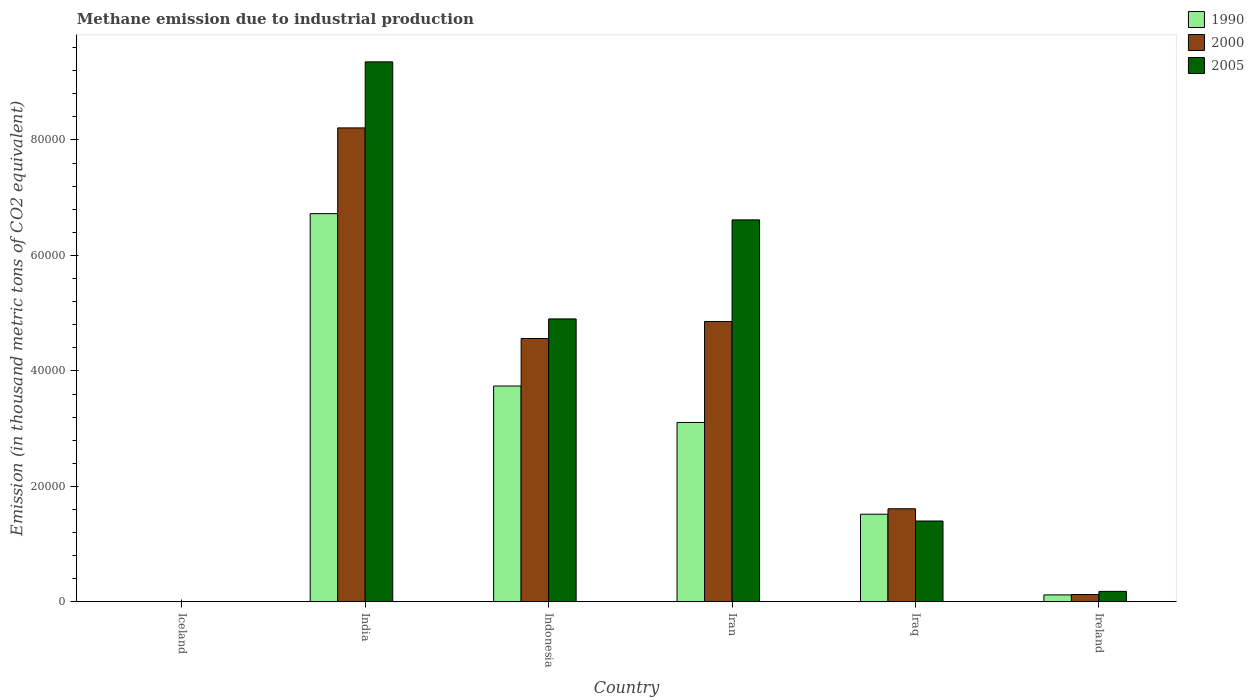How many groups of bars are there?
Offer a very short reply. 6. Are the number of bars on each tick of the X-axis equal?
Your response must be concise. Yes. How many bars are there on the 1st tick from the right?
Your response must be concise. 3. Across all countries, what is the maximum amount of methane emitted in 2000?
Provide a succinct answer. 8.21e+04. In which country was the amount of methane emitted in 2005 maximum?
Ensure brevity in your answer.  India. What is the total amount of methane emitted in 2000 in the graph?
Make the answer very short. 1.94e+05. What is the difference between the amount of methane emitted in 2000 in Indonesia and that in Iran?
Provide a succinct answer. -2945.6. What is the difference between the amount of methane emitted in 1990 in Ireland and the amount of methane emitted in 2000 in Iran?
Your answer should be very brief. -4.74e+04. What is the average amount of methane emitted in 2005 per country?
Your answer should be compact. 3.74e+04. What is the difference between the amount of methane emitted of/in 2000 and amount of methane emitted of/in 1990 in Ireland?
Your response must be concise. 68.5. What is the ratio of the amount of methane emitted in 2005 in Indonesia to that in Iran?
Your response must be concise. 0.74. Is the difference between the amount of methane emitted in 2000 in India and Ireland greater than the difference between the amount of methane emitted in 1990 in India and Ireland?
Keep it short and to the point. Yes. What is the difference between the highest and the second highest amount of methane emitted in 2005?
Provide a short and direct response. -4.45e+04. What is the difference between the highest and the lowest amount of methane emitted in 2000?
Your response must be concise. 8.21e+04. What does the 3rd bar from the left in India represents?
Provide a short and direct response. 2005. What is the difference between two consecutive major ticks on the Y-axis?
Ensure brevity in your answer.  2.00e+04. Does the graph contain any zero values?
Your response must be concise. No. Does the graph contain grids?
Ensure brevity in your answer.  No. How many legend labels are there?
Offer a very short reply. 3. What is the title of the graph?
Ensure brevity in your answer.  Methane emission due to industrial production. Does "1966" appear as one of the legend labels in the graph?
Your answer should be very brief. No. What is the label or title of the X-axis?
Make the answer very short. Country. What is the label or title of the Y-axis?
Offer a very short reply. Emission (in thousand metric tons of CO2 equivalent). What is the Emission (in thousand metric tons of CO2 equivalent) of 2000 in Iceland?
Provide a succinct answer. 5.6. What is the Emission (in thousand metric tons of CO2 equivalent) in 1990 in India?
Offer a terse response. 6.72e+04. What is the Emission (in thousand metric tons of CO2 equivalent) in 2000 in India?
Offer a terse response. 8.21e+04. What is the Emission (in thousand metric tons of CO2 equivalent) of 2005 in India?
Make the answer very short. 9.35e+04. What is the Emission (in thousand metric tons of CO2 equivalent) of 1990 in Indonesia?
Your answer should be compact. 3.74e+04. What is the Emission (in thousand metric tons of CO2 equivalent) in 2000 in Indonesia?
Provide a succinct answer. 4.56e+04. What is the Emission (in thousand metric tons of CO2 equivalent) of 2005 in Indonesia?
Give a very brief answer. 4.90e+04. What is the Emission (in thousand metric tons of CO2 equivalent) in 1990 in Iran?
Your answer should be compact. 3.11e+04. What is the Emission (in thousand metric tons of CO2 equivalent) of 2000 in Iran?
Make the answer very short. 4.86e+04. What is the Emission (in thousand metric tons of CO2 equivalent) in 2005 in Iran?
Offer a very short reply. 6.62e+04. What is the Emission (in thousand metric tons of CO2 equivalent) in 1990 in Iraq?
Give a very brief answer. 1.52e+04. What is the Emission (in thousand metric tons of CO2 equivalent) of 2000 in Iraq?
Give a very brief answer. 1.61e+04. What is the Emission (in thousand metric tons of CO2 equivalent) of 2005 in Iraq?
Keep it short and to the point. 1.40e+04. What is the Emission (in thousand metric tons of CO2 equivalent) of 1990 in Ireland?
Your response must be concise. 1208.4. What is the Emission (in thousand metric tons of CO2 equivalent) of 2000 in Ireland?
Make the answer very short. 1276.9. What is the Emission (in thousand metric tons of CO2 equivalent) of 2005 in Ireland?
Keep it short and to the point. 1817.5. Across all countries, what is the maximum Emission (in thousand metric tons of CO2 equivalent) in 1990?
Your answer should be compact. 6.72e+04. Across all countries, what is the maximum Emission (in thousand metric tons of CO2 equivalent) in 2000?
Provide a succinct answer. 8.21e+04. Across all countries, what is the maximum Emission (in thousand metric tons of CO2 equivalent) in 2005?
Provide a succinct answer. 9.35e+04. Across all countries, what is the minimum Emission (in thousand metric tons of CO2 equivalent) of 2005?
Keep it short and to the point. 4. What is the total Emission (in thousand metric tons of CO2 equivalent) in 1990 in the graph?
Your answer should be very brief. 1.52e+05. What is the total Emission (in thousand metric tons of CO2 equivalent) of 2000 in the graph?
Make the answer very short. 1.94e+05. What is the total Emission (in thousand metric tons of CO2 equivalent) of 2005 in the graph?
Make the answer very short. 2.25e+05. What is the difference between the Emission (in thousand metric tons of CO2 equivalent) in 1990 in Iceland and that in India?
Give a very brief answer. -6.72e+04. What is the difference between the Emission (in thousand metric tons of CO2 equivalent) in 2000 in Iceland and that in India?
Give a very brief answer. -8.21e+04. What is the difference between the Emission (in thousand metric tons of CO2 equivalent) of 2005 in Iceland and that in India?
Offer a terse response. -9.35e+04. What is the difference between the Emission (in thousand metric tons of CO2 equivalent) in 1990 in Iceland and that in Indonesia?
Provide a succinct answer. -3.74e+04. What is the difference between the Emission (in thousand metric tons of CO2 equivalent) of 2000 in Iceland and that in Indonesia?
Ensure brevity in your answer.  -4.56e+04. What is the difference between the Emission (in thousand metric tons of CO2 equivalent) in 2005 in Iceland and that in Indonesia?
Provide a short and direct response. -4.90e+04. What is the difference between the Emission (in thousand metric tons of CO2 equivalent) of 1990 in Iceland and that in Iran?
Make the answer very short. -3.11e+04. What is the difference between the Emission (in thousand metric tons of CO2 equivalent) in 2000 in Iceland and that in Iran?
Provide a short and direct response. -4.86e+04. What is the difference between the Emission (in thousand metric tons of CO2 equivalent) of 2005 in Iceland and that in Iran?
Offer a very short reply. -6.62e+04. What is the difference between the Emission (in thousand metric tons of CO2 equivalent) of 1990 in Iceland and that in Iraq?
Provide a succinct answer. -1.52e+04. What is the difference between the Emission (in thousand metric tons of CO2 equivalent) of 2000 in Iceland and that in Iraq?
Provide a short and direct response. -1.61e+04. What is the difference between the Emission (in thousand metric tons of CO2 equivalent) of 2005 in Iceland and that in Iraq?
Provide a succinct answer. -1.40e+04. What is the difference between the Emission (in thousand metric tons of CO2 equivalent) of 1990 in Iceland and that in Ireland?
Your answer should be very brief. -1201.4. What is the difference between the Emission (in thousand metric tons of CO2 equivalent) in 2000 in Iceland and that in Ireland?
Offer a terse response. -1271.3. What is the difference between the Emission (in thousand metric tons of CO2 equivalent) in 2005 in Iceland and that in Ireland?
Make the answer very short. -1813.5. What is the difference between the Emission (in thousand metric tons of CO2 equivalent) of 1990 in India and that in Indonesia?
Offer a terse response. 2.99e+04. What is the difference between the Emission (in thousand metric tons of CO2 equivalent) in 2000 in India and that in Indonesia?
Give a very brief answer. 3.65e+04. What is the difference between the Emission (in thousand metric tons of CO2 equivalent) in 2005 in India and that in Indonesia?
Provide a short and direct response. 4.45e+04. What is the difference between the Emission (in thousand metric tons of CO2 equivalent) of 1990 in India and that in Iran?
Ensure brevity in your answer.  3.62e+04. What is the difference between the Emission (in thousand metric tons of CO2 equivalent) of 2000 in India and that in Iran?
Ensure brevity in your answer.  3.35e+04. What is the difference between the Emission (in thousand metric tons of CO2 equivalent) in 2005 in India and that in Iran?
Offer a very short reply. 2.74e+04. What is the difference between the Emission (in thousand metric tons of CO2 equivalent) in 1990 in India and that in Iraq?
Provide a succinct answer. 5.21e+04. What is the difference between the Emission (in thousand metric tons of CO2 equivalent) of 2000 in India and that in Iraq?
Offer a terse response. 6.60e+04. What is the difference between the Emission (in thousand metric tons of CO2 equivalent) of 2005 in India and that in Iraq?
Give a very brief answer. 7.95e+04. What is the difference between the Emission (in thousand metric tons of CO2 equivalent) of 1990 in India and that in Ireland?
Your answer should be compact. 6.60e+04. What is the difference between the Emission (in thousand metric tons of CO2 equivalent) of 2000 in India and that in Ireland?
Provide a succinct answer. 8.08e+04. What is the difference between the Emission (in thousand metric tons of CO2 equivalent) of 2005 in India and that in Ireland?
Give a very brief answer. 9.17e+04. What is the difference between the Emission (in thousand metric tons of CO2 equivalent) in 1990 in Indonesia and that in Iran?
Provide a short and direct response. 6313.9. What is the difference between the Emission (in thousand metric tons of CO2 equivalent) of 2000 in Indonesia and that in Iran?
Make the answer very short. -2945.6. What is the difference between the Emission (in thousand metric tons of CO2 equivalent) of 2005 in Indonesia and that in Iran?
Your answer should be compact. -1.72e+04. What is the difference between the Emission (in thousand metric tons of CO2 equivalent) of 1990 in Indonesia and that in Iraq?
Make the answer very short. 2.22e+04. What is the difference between the Emission (in thousand metric tons of CO2 equivalent) in 2000 in Indonesia and that in Iraq?
Your answer should be very brief. 2.95e+04. What is the difference between the Emission (in thousand metric tons of CO2 equivalent) of 2005 in Indonesia and that in Iraq?
Offer a very short reply. 3.50e+04. What is the difference between the Emission (in thousand metric tons of CO2 equivalent) of 1990 in Indonesia and that in Ireland?
Offer a very short reply. 3.62e+04. What is the difference between the Emission (in thousand metric tons of CO2 equivalent) of 2000 in Indonesia and that in Ireland?
Your response must be concise. 4.43e+04. What is the difference between the Emission (in thousand metric tons of CO2 equivalent) of 2005 in Indonesia and that in Ireland?
Make the answer very short. 4.72e+04. What is the difference between the Emission (in thousand metric tons of CO2 equivalent) in 1990 in Iran and that in Iraq?
Make the answer very short. 1.59e+04. What is the difference between the Emission (in thousand metric tons of CO2 equivalent) in 2000 in Iran and that in Iraq?
Give a very brief answer. 3.24e+04. What is the difference between the Emission (in thousand metric tons of CO2 equivalent) of 2005 in Iran and that in Iraq?
Keep it short and to the point. 5.22e+04. What is the difference between the Emission (in thousand metric tons of CO2 equivalent) in 1990 in Iran and that in Ireland?
Make the answer very short. 2.99e+04. What is the difference between the Emission (in thousand metric tons of CO2 equivalent) of 2000 in Iran and that in Ireland?
Give a very brief answer. 4.73e+04. What is the difference between the Emission (in thousand metric tons of CO2 equivalent) of 2005 in Iran and that in Ireland?
Your answer should be compact. 6.43e+04. What is the difference between the Emission (in thousand metric tons of CO2 equivalent) in 1990 in Iraq and that in Ireland?
Give a very brief answer. 1.40e+04. What is the difference between the Emission (in thousand metric tons of CO2 equivalent) of 2000 in Iraq and that in Ireland?
Your response must be concise. 1.48e+04. What is the difference between the Emission (in thousand metric tons of CO2 equivalent) in 2005 in Iraq and that in Ireland?
Your answer should be very brief. 1.22e+04. What is the difference between the Emission (in thousand metric tons of CO2 equivalent) in 1990 in Iceland and the Emission (in thousand metric tons of CO2 equivalent) in 2000 in India?
Your answer should be very brief. -8.21e+04. What is the difference between the Emission (in thousand metric tons of CO2 equivalent) in 1990 in Iceland and the Emission (in thousand metric tons of CO2 equivalent) in 2005 in India?
Keep it short and to the point. -9.35e+04. What is the difference between the Emission (in thousand metric tons of CO2 equivalent) in 2000 in Iceland and the Emission (in thousand metric tons of CO2 equivalent) in 2005 in India?
Give a very brief answer. -9.35e+04. What is the difference between the Emission (in thousand metric tons of CO2 equivalent) of 1990 in Iceland and the Emission (in thousand metric tons of CO2 equivalent) of 2000 in Indonesia?
Give a very brief answer. -4.56e+04. What is the difference between the Emission (in thousand metric tons of CO2 equivalent) in 1990 in Iceland and the Emission (in thousand metric tons of CO2 equivalent) in 2005 in Indonesia?
Offer a very short reply. -4.90e+04. What is the difference between the Emission (in thousand metric tons of CO2 equivalent) in 2000 in Iceland and the Emission (in thousand metric tons of CO2 equivalent) in 2005 in Indonesia?
Provide a short and direct response. -4.90e+04. What is the difference between the Emission (in thousand metric tons of CO2 equivalent) in 1990 in Iceland and the Emission (in thousand metric tons of CO2 equivalent) in 2000 in Iran?
Ensure brevity in your answer.  -4.86e+04. What is the difference between the Emission (in thousand metric tons of CO2 equivalent) in 1990 in Iceland and the Emission (in thousand metric tons of CO2 equivalent) in 2005 in Iran?
Offer a very short reply. -6.62e+04. What is the difference between the Emission (in thousand metric tons of CO2 equivalent) in 2000 in Iceland and the Emission (in thousand metric tons of CO2 equivalent) in 2005 in Iran?
Offer a very short reply. -6.62e+04. What is the difference between the Emission (in thousand metric tons of CO2 equivalent) in 1990 in Iceland and the Emission (in thousand metric tons of CO2 equivalent) in 2000 in Iraq?
Your answer should be very brief. -1.61e+04. What is the difference between the Emission (in thousand metric tons of CO2 equivalent) of 1990 in Iceland and the Emission (in thousand metric tons of CO2 equivalent) of 2005 in Iraq?
Provide a succinct answer. -1.40e+04. What is the difference between the Emission (in thousand metric tons of CO2 equivalent) in 2000 in Iceland and the Emission (in thousand metric tons of CO2 equivalent) in 2005 in Iraq?
Give a very brief answer. -1.40e+04. What is the difference between the Emission (in thousand metric tons of CO2 equivalent) of 1990 in Iceland and the Emission (in thousand metric tons of CO2 equivalent) of 2000 in Ireland?
Your answer should be very brief. -1269.9. What is the difference between the Emission (in thousand metric tons of CO2 equivalent) of 1990 in Iceland and the Emission (in thousand metric tons of CO2 equivalent) of 2005 in Ireland?
Make the answer very short. -1810.5. What is the difference between the Emission (in thousand metric tons of CO2 equivalent) of 2000 in Iceland and the Emission (in thousand metric tons of CO2 equivalent) of 2005 in Ireland?
Give a very brief answer. -1811.9. What is the difference between the Emission (in thousand metric tons of CO2 equivalent) of 1990 in India and the Emission (in thousand metric tons of CO2 equivalent) of 2000 in Indonesia?
Your response must be concise. 2.16e+04. What is the difference between the Emission (in thousand metric tons of CO2 equivalent) of 1990 in India and the Emission (in thousand metric tons of CO2 equivalent) of 2005 in Indonesia?
Your response must be concise. 1.82e+04. What is the difference between the Emission (in thousand metric tons of CO2 equivalent) in 2000 in India and the Emission (in thousand metric tons of CO2 equivalent) in 2005 in Indonesia?
Make the answer very short. 3.31e+04. What is the difference between the Emission (in thousand metric tons of CO2 equivalent) in 1990 in India and the Emission (in thousand metric tons of CO2 equivalent) in 2000 in Iran?
Make the answer very short. 1.87e+04. What is the difference between the Emission (in thousand metric tons of CO2 equivalent) of 1990 in India and the Emission (in thousand metric tons of CO2 equivalent) of 2005 in Iran?
Your response must be concise. 1080. What is the difference between the Emission (in thousand metric tons of CO2 equivalent) of 2000 in India and the Emission (in thousand metric tons of CO2 equivalent) of 2005 in Iran?
Offer a very short reply. 1.59e+04. What is the difference between the Emission (in thousand metric tons of CO2 equivalent) in 1990 in India and the Emission (in thousand metric tons of CO2 equivalent) in 2000 in Iraq?
Provide a succinct answer. 5.11e+04. What is the difference between the Emission (in thousand metric tons of CO2 equivalent) of 1990 in India and the Emission (in thousand metric tons of CO2 equivalent) of 2005 in Iraq?
Provide a succinct answer. 5.32e+04. What is the difference between the Emission (in thousand metric tons of CO2 equivalent) of 2000 in India and the Emission (in thousand metric tons of CO2 equivalent) of 2005 in Iraq?
Your response must be concise. 6.81e+04. What is the difference between the Emission (in thousand metric tons of CO2 equivalent) of 1990 in India and the Emission (in thousand metric tons of CO2 equivalent) of 2000 in Ireland?
Your response must be concise. 6.60e+04. What is the difference between the Emission (in thousand metric tons of CO2 equivalent) in 1990 in India and the Emission (in thousand metric tons of CO2 equivalent) in 2005 in Ireland?
Offer a terse response. 6.54e+04. What is the difference between the Emission (in thousand metric tons of CO2 equivalent) of 2000 in India and the Emission (in thousand metric tons of CO2 equivalent) of 2005 in Ireland?
Your answer should be compact. 8.03e+04. What is the difference between the Emission (in thousand metric tons of CO2 equivalent) of 1990 in Indonesia and the Emission (in thousand metric tons of CO2 equivalent) of 2000 in Iran?
Make the answer very short. -1.12e+04. What is the difference between the Emission (in thousand metric tons of CO2 equivalent) in 1990 in Indonesia and the Emission (in thousand metric tons of CO2 equivalent) in 2005 in Iran?
Give a very brief answer. -2.88e+04. What is the difference between the Emission (in thousand metric tons of CO2 equivalent) of 2000 in Indonesia and the Emission (in thousand metric tons of CO2 equivalent) of 2005 in Iran?
Provide a succinct answer. -2.05e+04. What is the difference between the Emission (in thousand metric tons of CO2 equivalent) in 1990 in Indonesia and the Emission (in thousand metric tons of CO2 equivalent) in 2000 in Iraq?
Offer a terse response. 2.13e+04. What is the difference between the Emission (in thousand metric tons of CO2 equivalent) in 1990 in Indonesia and the Emission (in thousand metric tons of CO2 equivalent) in 2005 in Iraq?
Provide a short and direct response. 2.34e+04. What is the difference between the Emission (in thousand metric tons of CO2 equivalent) in 2000 in Indonesia and the Emission (in thousand metric tons of CO2 equivalent) in 2005 in Iraq?
Provide a short and direct response. 3.16e+04. What is the difference between the Emission (in thousand metric tons of CO2 equivalent) of 1990 in Indonesia and the Emission (in thousand metric tons of CO2 equivalent) of 2000 in Ireland?
Give a very brief answer. 3.61e+04. What is the difference between the Emission (in thousand metric tons of CO2 equivalent) of 1990 in Indonesia and the Emission (in thousand metric tons of CO2 equivalent) of 2005 in Ireland?
Keep it short and to the point. 3.56e+04. What is the difference between the Emission (in thousand metric tons of CO2 equivalent) in 2000 in Indonesia and the Emission (in thousand metric tons of CO2 equivalent) in 2005 in Ireland?
Ensure brevity in your answer.  4.38e+04. What is the difference between the Emission (in thousand metric tons of CO2 equivalent) of 1990 in Iran and the Emission (in thousand metric tons of CO2 equivalent) of 2000 in Iraq?
Give a very brief answer. 1.49e+04. What is the difference between the Emission (in thousand metric tons of CO2 equivalent) of 1990 in Iran and the Emission (in thousand metric tons of CO2 equivalent) of 2005 in Iraq?
Your answer should be very brief. 1.71e+04. What is the difference between the Emission (in thousand metric tons of CO2 equivalent) of 2000 in Iran and the Emission (in thousand metric tons of CO2 equivalent) of 2005 in Iraq?
Your answer should be compact. 3.46e+04. What is the difference between the Emission (in thousand metric tons of CO2 equivalent) in 1990 in Iran and the Emission (in thousand metric tons of CO2 equivalent) in 2000 in Ireland?
Your response must be concise. 2.98e+04. What is the difference between the Emission (in thousand metric tons of CO2 equivalent) in 1990 in Iran and the Emission (in thousand metric tons of CO2 equivalent) in 2005 in Ireland?
Provide a short and direct response. 2.93e+04. What is the difference between the Emission (in thousand metric tons of CO2 equivalent) of 2000 in Iran and the Emission (in thousand metric tons of CO2 equivalent) of 2005 in Ireland?
Ensure brevity in your answer.  4.67e+04. What is the difference between the Emission (in thousand metric tons of CO2 equivalent) of 1990 in Iraq and the Emission (in thousand metric tons of CO2 equivalent) of 2000 in Ireland?
Make the answer very short. 1.39e+04. What is the difference between the Emission (in thousand metric tons of CO2 equivalent) in 1990 in Iraq and the Emission (in thousand metric tons of CO2 equivalent) in 2005 in Ireland?
Give a very brief answer. 1.34e+04. What is the difference between the Emission (in thousand metric tons of CO2 equivalent) in 2000 in Iraq and the Emission (in thousand metric tons of CO2 equivalent) in 2005 in Ireland?
Provide a short and direct response. 1.43e+04. What is the average Emission (in thousand metric tons of CO2 equivalent) of 1990 per country?
Make the answer very short. 2.53e+04. What is the average Emission (in thousand metric tons of CO2 equivalent) in 2000 per country?
Provide a short and direct response. 3.23e+04. What is the average Emission (in thousand metric tons of CO2 equivalent) of 2005 per country?
Ensure brevity in your answer.  3.74e+04. What is the difference between the Emission (in thousand metric tons of CO2 equivalent) in 1990 and Emission (in thousand metric tons of CO2 equivalent) in 2000 in Iceland?
Ensure brevity in your answer.  1.4. What is the difference between the Emission (in thousand metric tons of CO2 equivalent) in 1990 and Emission (in thousand metric tons of CO2 equivalent) in 2005 in Iceland?
Ensure brevity in your answer.  3. What is the difference between the Emission (in thousand metric tons of CO2 equivalent) of 1990 and Emission (in thousand metric tons of CO2 equivalent) of 2000 in India?
Keep it short and to the point. -1.49e+04. What is the difference between the Emission (in thousand metric tons of CO2 equivalent) in 1990 and Emission (in thousand metric tons of CO2 equivalent) in 2005 in India?
Your answer should be very brief. -2.63e+04. What is the difference between the Emission (in thousand metric tons of CO2 equivalent) in 2000 and Emission (in thousand metric tons of CO2 equivalent) in 2005 in India?
Provide a short and direct response. -1.14e+04. What is the difference between the Emission (in thousand metric tons of CO2 equivalent) of 1990 and Emission (in thousand metric tons of CO2 equivalent) of 2000 in Indonesia?
Give a very brief answer. -8228.1. What is the difference between the Emission (in thousand metric tons of CO2 equivalent) in 1990 and Emission (in thousand metric tons of CO2 equivalent) in 2005 in Indonesia?
Offer a terse response. -1.16e+04. What is the difference between the Emission (in thousand metric tons of CO2 equivalent) of 2000 and Emission (in thousand metric tons of CO2 equivalent) of 2005 in Indonesia?
Keep it short and to the point. -3391.6. What is the difference between the Emission (in thousand metric tons of CO2 equivalent) of 1990 and Emission (in thousand metric tons of CO2 equivalent) of 2000 in Iran?
Give a very brief answer. -1.75e+04. What is the difference between the Emission (in thousand metric tons of CO2 equivalent) of 1990 and Emission (in thousand metric tons of CO2 equivalent) of 2005 in Iran?
Provide a succinct answer. -3.51e+04. What is the difference between the Emission (in thousand metric tons of CO2 equivalent) in 2000 and Emission (in thousand metric tons of CO2 equivalent) in 2005 in Iran?
Provide a succinct answer. -1.76e+04. What is the difference between the Emission (in thousand metric tons of CO2 equivalent) of 1990 and Emission (in thousand metric tons of CO2 equivalent) of 2000 in Iraq?
Keep it short and to the point. -942.5. What is the difference between the Emission (in thousand metric tons of CO2 equivalent) in 1990 and Emission (in thousand metric tons of CO2 equivalent) in 2005 in Iraq?
Offer a very short reply. 1177.5. What is the difference between the Emission (in thousand metric tons of CO2 equivalent) of 2000 and Emission (in thousand metric tons of CO2 equivalent) of 2005 in Iraq?
Your answer should be very brief. 2120. What is the difference between the Emission (in thousand metric tons of CO2 equivalent) in 1990 and Emission (in thousand metric tons of CO2 equivalent) in 2000 in Ireland?
Keep it short and to the point. -68.5. What is the difference between the Emission (in thousand metric tons of CO2 equivalent) of 1990 and Emission (in thousand metric tons of CO2 equivalent) of 2005 in Ireland?
Give a very brief answer. -609.1. What is the difference between the Emission (in thousand metric tons of CO2 equivalent) in 2000 and Emission (in thousand metric tons of CO2 equivalent) in 2005 in Ireland?
Provide a succinct answer. -540.6. What is the ratio of the Emission (in thousand metric tons of CO2 equivalent) of 2005 in Iceland to that in India?
Your answer should be very brief. 0. What is the ratio of the Emission (in thousand metric tons of CO2 equivalent) in 1990 in Iceland to that in Indonesia?
Provide a short and direct response. 0. What is the ratio of the Emission (in thousand metric tons of CO2 equivalent) of 2005 in Iceland to that in Indonesia?
Keep it short and to the point. 0. What is the ratio of the Emission (in thousand metric tons of CO2 equivalent) of 1990 in Iceland to that in Iran?
Offer a terse response. 0. What is the ratio of the Emission (in thousand metric tons of CO2 equivalent) in 2000 in Iceland to that in Iran?
Offer a very short reply. 0. What is the ratio of the Emission (in thousand metric tons of CO2 equivalent) in 2005 in Iceland to that in Iran?
Provide a short and direct response. 0. What is the ratio of the Emission (in thousand metric tons of CO2 equivalent) in 1990 in Iceland to that in Ireland?
Provide a short and direct response. 0.01. What is the ratio of the Emission (in thousand metric tons of CO2 equivalent) in 2000 in Iceland to that in Ireland?
Keep it short and to the point. 0. What is the ratio of the Emission (in thousand metric tons of CO2 equivalent) in 2005 in Iceland to that in Ireland?
Offer a very short reply. 0. What is the ratio of the Emission (in thousand metric tons of CO2 equivalent) of 1990 in India to that in Indonesia?
Make the answer very short. 1.8. What is the ratio of the Emission (in thousand metric tons of CO2 equivalent) in 2000 in India to that in Indonesia?
Provide a short and direct response. 1.8. What is the ratio of the Emission (in thousand metric tons of CO2 equivalent) in 2005 in India to that in Indonesia?
Ensure brevity in your answer.  1.91. What is the ratio of the Emission (in thousand metric tons of CO2 equivalent) of 1990 in India to that in Iran?
Your answer should be compact. 2.16. What is the ratio of the Emission (in thousand metric tons of CO2 equivalent) in 2000 in India to that in Iran?
Ensure brevity in your answer.  1.69. What is the ratio of the Emission (in thousand metric tons of CO2 equivalent) in 2005 in India to that in Iran?
Your answer should be very brief. 1.41. What is the ratio of the Emission (in thousand metric tons of CO2 equivalent) of 1990 in India to that in Iraq?
Give a very brief answer. 4.43. What is the ratio of the Emission (in thousand metric tons of CO2 equivalent) of 2000 in India to that in Iraq?
Offer a terse response. 5.09. What is the ratio of the Emission (in thousand metric tons of CO2 equivalent) of 2005 in India to that in Iraq?
Offer a terse response. 6.68. What is the ratio of the Emission (in thousand metric tons of CO2 equivalent) of 1990 in India to that in Ireland?
Ensure brevity in your answer.  55.64. What is the ratio of the Emission (in thousand metric tons of CO2 equivalent) in 2000 in India to that in Ireland?
Your answer should be very brief. 64.29. What is the ratio of the Emission (in thousand metric tons of CO2 equivalent) in 2005 in India to that in Ireland?
Your answer should be compact. 51.46. What is the ratio of the Emission (in thousand metric tons of CO2 equivalent) of 1990 in Indonesia to that in Iran?
Give a very brief answer. 1.2. What is the ratio of the Emission (in thousand metric tons of CO2 equivalent) of 2000 in Indonesia to that in Iran?
Provide a succinct answer. 0.94. What is the ratio of the Emission (in thousand metric tons of CO2 equivalent) of 2005 in Indonesia to that in Iran?
Ensure brevity in your answer.  0.74. What is the ratio of the Emission (in thousand metric tons of CO2 equivalent) in 1990 in Indonesia to that in Iraq?
Ensure brevity in your answer.  2.46. What is the ratio of the Emission (in thousand metric tons of CO2 equivalent) of 2000 in Indonesia to that in Iraq?
Offer a terse response. 2.83. What is the ratio of the Emission (in thousand metric tons of CO2 equivalent) of 2005 in Indonesia to that in Iraq?
Give a very brief answer. 3.5. What is the ratio of the Emission (in thousand metric tons of CO2 equivalent) of 1990 in Indonesia to that in Ireland?
Keep it short and to the point. 30.94. What is the ratio of the Emission (in thousand metric tons of CO2 equivalent) in 2000 in Indonesia to that in Ireland?
Keep it short and to the point. 35.72. What is the ratio of the Emission (in thousand metric tons of CO2 equivalent) of 2005 in Indonesia to that in Ireland?
Keep it short and to the point. 26.96. What is the ratio of the Emission (in thousand metric tons of CO2 equivalent) of 1990 in Iran to that in Iraq?
Provide a succinct answer. 2.05. What is the ratio of the Emission (in thousand metric tons of CO2 equivalent) in 2000 in Iran to that in Iraq?
Provide a short and direct response. 3.01. What is the ratio of the Emission (in thousand metric tons of CO2 equivalent) in 2005 in Iran to that in Iraq?
Your response must be concise. 4.72. What is the ratio of the Emission (in thousand metric tons of CO2 equivalent) in 1990 in Iran to that in Ireland?
Provide a short and direct response. 25.71. What is the ratio of the Emission (in thousand metric tons of CO2 equivalent) in 2000 in Iran to that in Ireland?
Your answer should be compact. 38.03. What is the ratio of the Emission (in thousand metric tons of CO2 equivalent) in 2005 in Iran to that in Ireland?
Your answer should be compact. 36.4. What is the ratio of the Emission (in thousand metric tons of CO2 equivalent) of 1990 in Iraq to that in Ireland?
Make the answer very short. 12.56. What is the ratio of the Emission (in thousand metric tons of CO2 equivalent) of 2000 in Iraq to that in Ireland?
Your answer should be compact. 12.63. What is the ratio of the Emission (in thousand metric tons of CO2 equivalent) of 2005 in Iraq to that in Ireland?
Your response must be concise. 7.71. What is the difference between the highest and the second highest Emission (in thousand metric tons of CO2 equivalent) in 1990?
Provide a succinct answer. 2.99e+04. What is the difference between the highest and the second highest Emission (in thousand metric tons of CO2 equivalent) of 2000?
Offer a very short reply. 3.35e+04. What is the difference between the highest and the second highest Emission (in thousand metric tons of CO2 equivalent) of 2005?
Your response must be concise. 2.74e+04. What is the difference between the highest and the lowest Emission (in thousand metric tons of CO2 equivalent) of 1990?
Give a very brief answer. 6.72e+04. What is the difference between the highest and the lowest Emission (in thousand metric tons of CO2 equivalent) in 2000?
Ensure brevity in your answer.  8.21e+04. What is the difference between the highest and the lowest Emission (in thousand metric tons of CO2 equivalent) in 2005?
Offer a very short reply. 9.35e+04. 